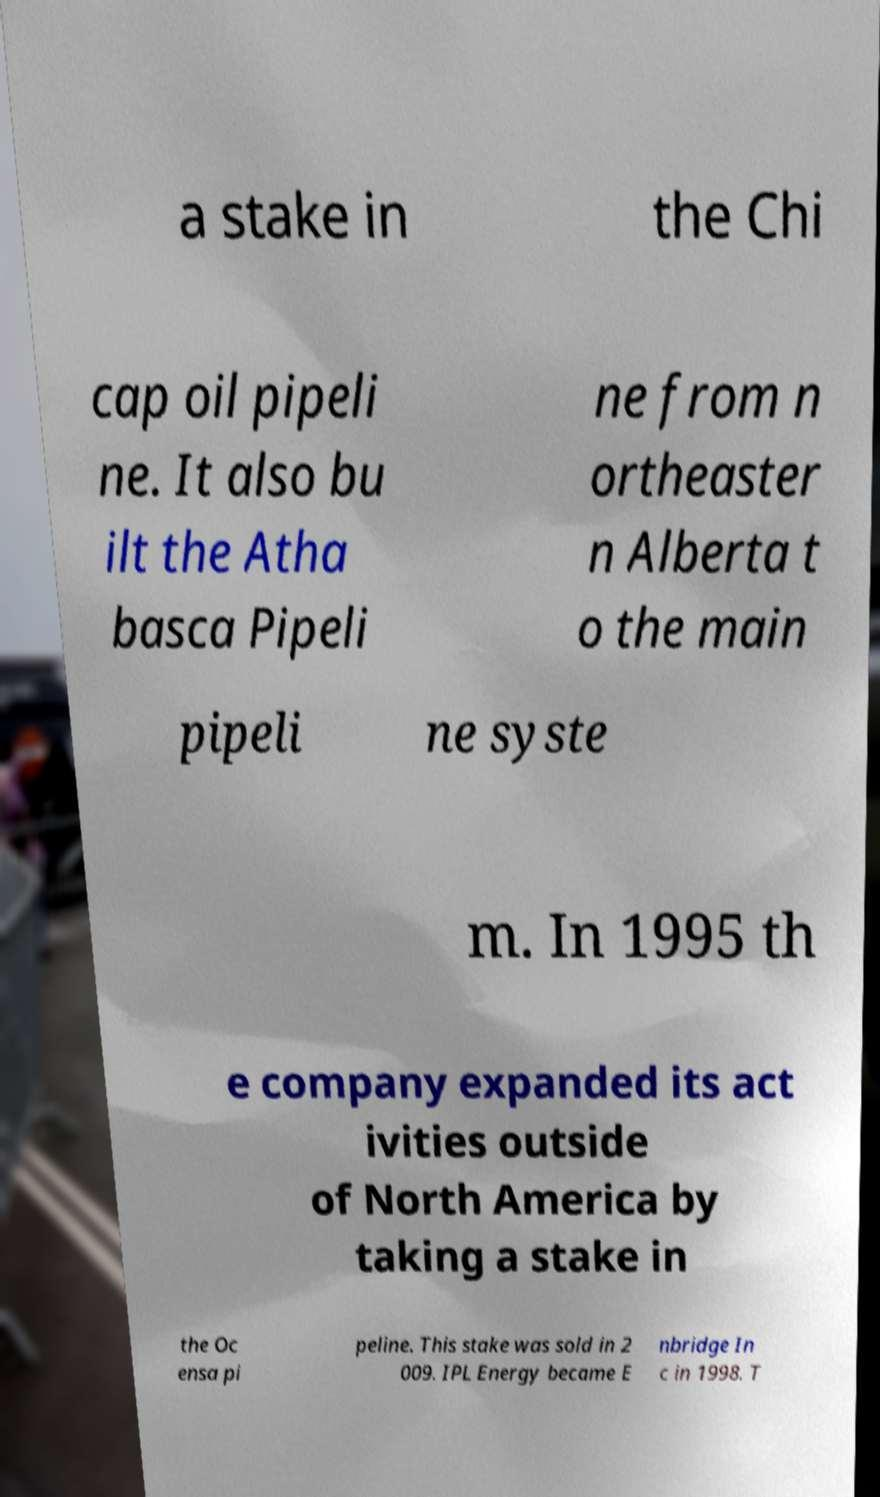I need the written content from this picture converted into text. Can you do that? a stake in the Chi cap oil pipeli ne. It also bu ilt the Atha basca Pipeli ne from n ortheaster n Alberta t o the main pipeli ne syste m. In 1995 th e company expanded its act ivities outside of North America by taking a stake in the Oc ensa pi peline. This stake was sold in 2 009. IPL Energy became E nbridge In c in 1998. T 